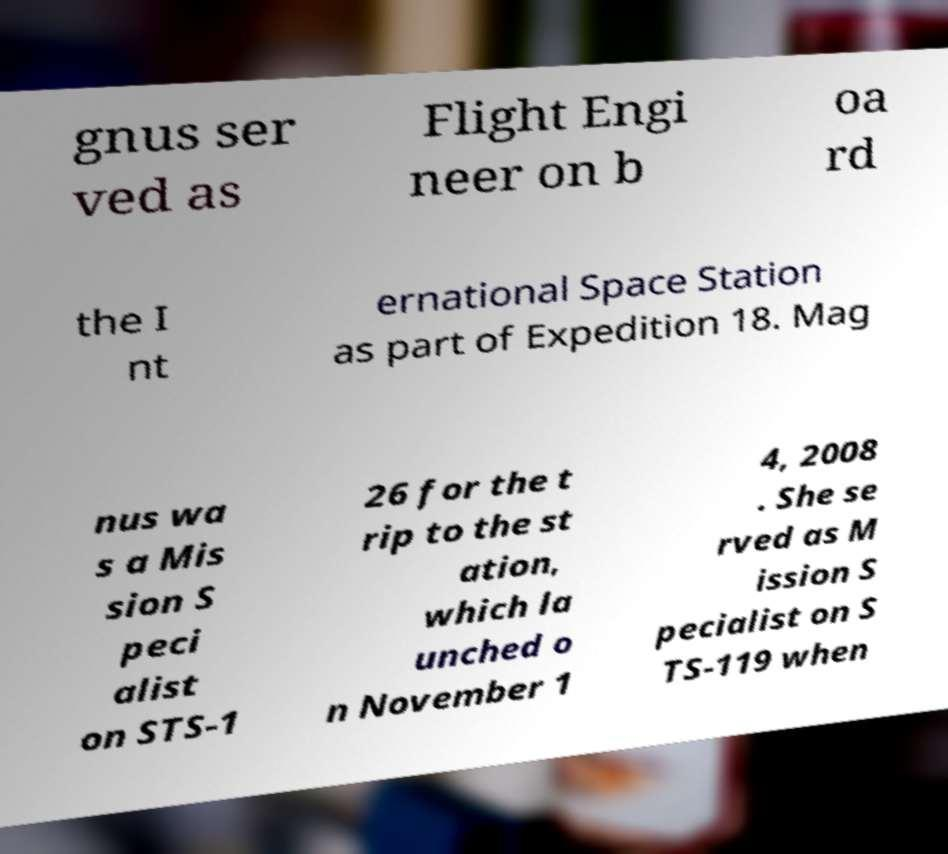There's text embedded in this image that I need extracted. Can you transcribe it verbatim? gnus ser ved as Flight Engi neer on b oa rd the I nt ernational Space Station as part of Expedition 18. Mag nus wa s a Mis sion S peci alist on STS-1 26 for the t rip to the st ation, which la unched o n November 1 4, 2008 . She se rved as M ission S pecialist on S TS-119 when 